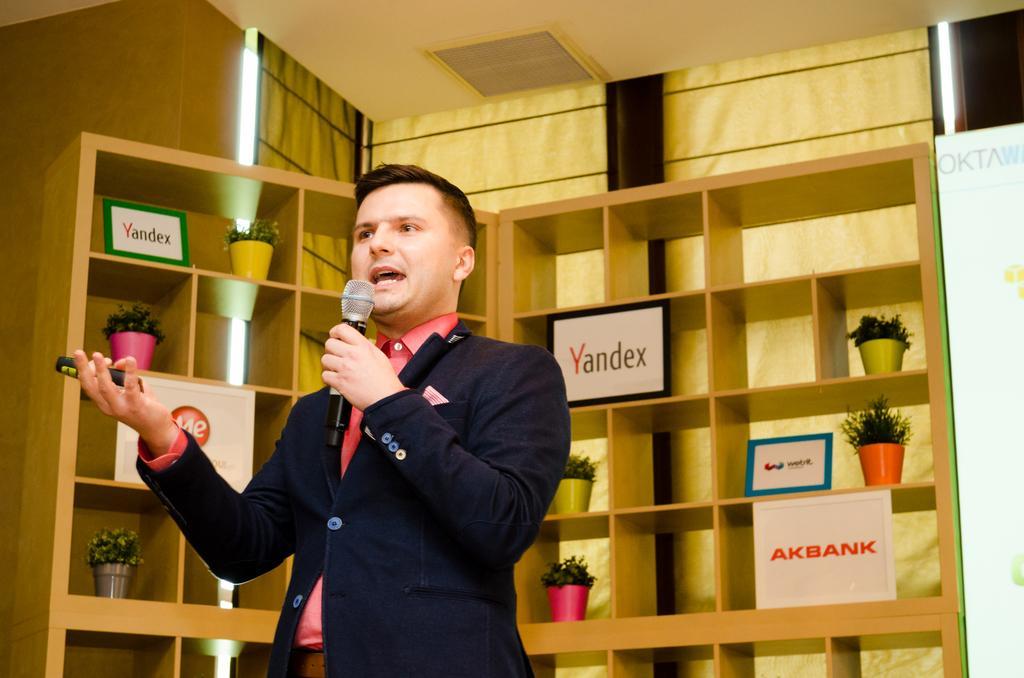Please provide a concise description of this image. In this picture we can see a person, he is holding a mic and in the background we can see houseplants, name frames, shelves, wall, roof and some objects. 